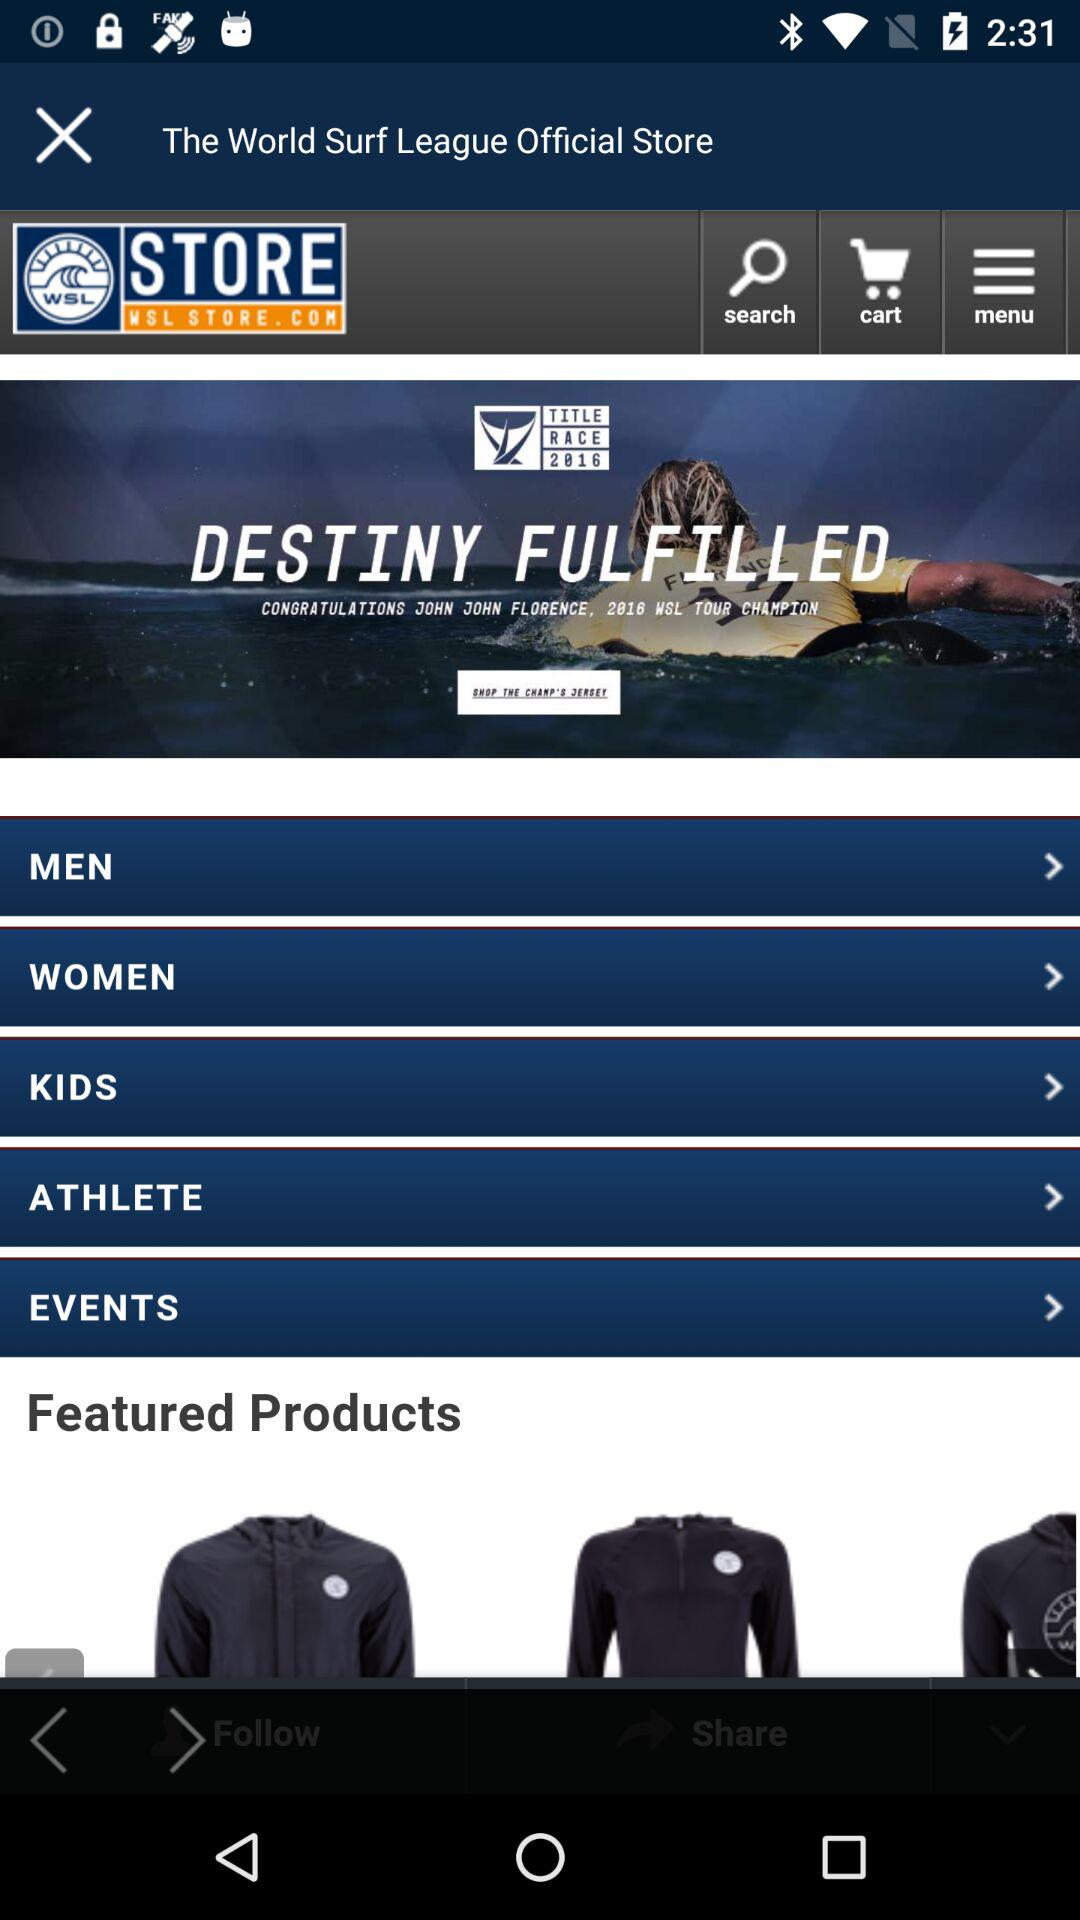What is the name of application? The name of the application is "WSL STORE. COM". 